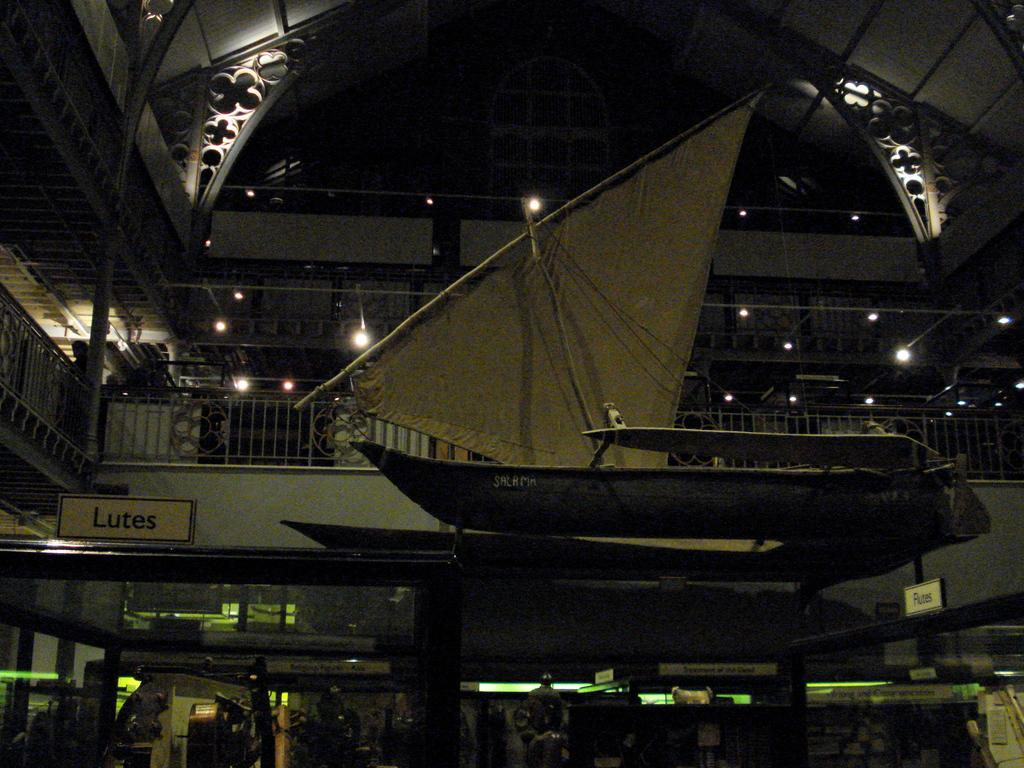What type of location is depicted in the image? The image is an inside picture of a building. What kind of structure can be seen in the building? There is a structure of a boat in the image. What type of barrier is present in the image? There is a metal fence in the image. What can be used for illumination in the image? There are lights in the image. What type of identification is present in the image? There are name plates in the image. What type of establishment can be found in the building? There are shops in the image. What type of alarm is going off in the image? There is no alarm present in the image. How many heads can be seen in the image? There is no information about heads or people in the image, as it focuses on the building's interior and its contents. 